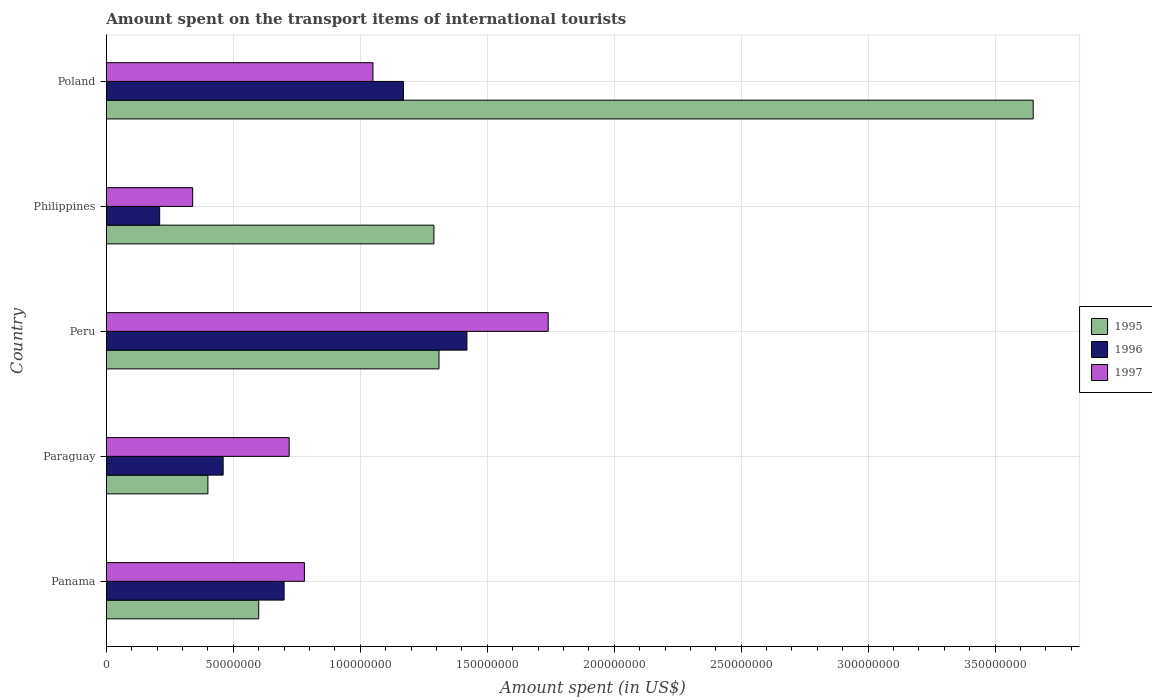Are the number of bars per tick equal to the number of legend labels?
Offer a terse response. Yes. Are the number of bars on each tick of the Y-axis equal?
Give a very brief answer. Yes. What is the label of the 4th group of bars from the top?
Your answer should be very brief. Paraguay. What is the amount spent on the transport items of international tourists in 1995 in Poland?
Offer a very short reply. 3.65e+08. Across all countries, what is the maximum amount spent on the transport items of international tourists in 1997?
Give a very brief answer. 1.74e+08. Across all countries, what is the minimum amount spent on the transport items of international tourists in 1997?
Your response must be concise. 3.40e+07. What is the total amount spent on the transport items of international tourists in 1995 in the graph?
Give a very brief answer. 7.25e+08. What is the difference between the amount spent on the transport items of international tourists in 1995 in Panama and that in Philippines?
Your answer should be very brief. -6.90e+07. What is the difference between the amount spent on the transport items of international tourists in 1996 in Peru and the amount spent on the transport items of international tourists in 1995 in Philippines?
Keep it short and to the point. 1.30e+07. What is the average amount spent on the transport items of international tourists in 1996 per country?
Offer a terse response. 7.92e+07. What is the difference between the amount spent on the transport items of international tourists in 1995 and amount spent on the transport items of international tourists in 1997 in Panama?
Provide a succinct answer. -1.80e+07. What is the ratio of the amount spent on the transport items of international tourists in 1996 in Peru to that in Poland?
Provide a short and direct response. 1.21. What is the difference between the highest and the second highest amount spent on the transport items of international tourists in 1996?
Your answer should be very brief. 2.50e+07. What is the difference between the highest and the lowest amount spent on the transport items of international tourists in 1996?
Provide a succinct answer. 1.21e+08. What does the 2nd bar from the top in Panama represents?
Your answer should be compact. 1996. What does the 1st bar from the bottom in Peru represents?
Keep it short and to the point. 1995. How many bars are there?
Provide a succinct answer. 15. Are all the bars in the graph horizontal?
Offer a terse response. Yes. What is the difference between two consecutive major ticks on the X-axis?
Provide a succinct answer. 5.00e+07. Does the graph contain any zero values?
Your answer should be compact. No. Where does the legend appear in the graph?
Offer a very short reply. Center right. How are the legend labels stacked?
Offer a very short reply. Vertical. What is the title of the graph?
Your answer should be very brief. Amount spent on the transport items of international tourists. What is the label or title of the X-axis?
Offer a terse response. Amount spent (in US$). What is the label or title of the Y-axis?
Make the answer very short. Country. What is the Amount spent (in US$) of 1995 in Panama?
Give a very brief answer. 6.00e+07. What is the Amount spent (in US$) in 1996 in Panama?
Your answer should be compact. 7.00e+07. What is the Amount spent (in US$) in 1997 in Panama?
Your answer should be very brief. 7.80e+07. What is the Amount spent (in US$) in 1995 in Paraguay?
Your answer should be compact. 4.00e+07. What is the Amount spent (in US$) in 1996 in Paraguay?
Ensure brevity in your answer.  4.60e+07. What is the Amount spent (in US$) of 1997 in Paraguay?
Your response must be concise. 7.20e+07. What is the Amount spent (in US$) of 1995 in Peru?
Your answer should be compact. 1.31e+08. What is the Amount spent (in US$) in 1996 in Peru?
Keep it short and to the point. 1.42e+08. What is the Amount spent (in US$) in 1997 in Peru?
Offer a terse response. 1.74e+08. What is the Amount spent (in US$) of 1995 in Philippines?
Your answer should be compact. 1.29e+08. What is the Amount spent (in US$) of 1996 in Philippines?
Your response must be concise. 2.10e+07. What is the Amount spent (in US$) of 1997 in Philippines?
Provide a short and direct response. 3.40e+07. What is the Amount spent (in US$) of 1995 in Poland?
Your answer should be very brief. 3.65e+08. What is the Amount spent (in US$) of 1996 in Poland?
Your answer should be compact. 1.17e+08. What is the Amount spent (in US$) in 1997 in Poland?
Make the answer very short. 1.05e+08. Across all countries, what is the maximum Amount spent (in US$) in 1995?
Your response must be concise. 3.65e+08. Across all countries, what is the maximum Amount spent (in US$) of 1996?
Provide a succinct answer. 1.42e+08. Across all countries, what is the maximum Amount spent (in US$) in 1997?
Your answer should be compact. 1.74e+08. Across all countries, what is the minimum Amount spent (in US$) of 1995?
Your answer should be very brief. 4.00e+07. Across all countries, what is the minimum Amount spent (in US$) of 1996?
Keep it short and to the point. 2.10e+07. Across all countries, what is the minimum Amount spent (in US$) in 1997?
Offer a very short reply. 3.40e+07. What is the total Amount spent (in US$) in 1995 in the graph?
Keep it short and to the point. 7.25e+08. What is the total Amount spent (in US$) of 1996 in the graph?
Keep it short and to the point. 3.96e+08. What is the total Amount spent (in US$) of 1997 in the graph?
Provide a short and direct response. 4.63e+08. What is the difference between the Amount spent (in US$) in 1996 in Panama and that in Paraguay?
Your answer should be very brief. 2.40e+07. What is the difference between the Amount spent (in US$) in 1995 in Panama and that in Peru?
Offer a terse response. -7.10e+07. What is the difference between the Amount spent (in US$) of 1996 in Panama and that in Peru?
Your answer should be very brief. -7.20e+07. What is the difference between the Amount spent (in US$) of 1997 in Panama and that in Peru?
Keep it short and to the point. -9.60e+07. What is the difference between the Amount spent (in US$) of 1995 in Panama and that in Philippines?
Offer a terse response. -6.90e+07. What is the difference between the Amount spent (in US$) of 1996 in Panama and that in Philippines?
Provide a short and direct response. 4.90e+07. What is the difference between the Amount spent (in US$) of 1997 in Panama and that in Philippines?
Provide a short and direct response. 4.40e+07. What is the difference between the Amount spent (in US$) in 1995 in Panama and that in Poland?
Your answer should be compact. -3.05e+08. What is the difference between the Amount spent (in US$) of 1996 in Panama and that in Poland?
Give a very brief answer. -4.70e+07. What is the difference between the Amount spent (in US$) of 1997 in Panama and that in Poland?
Offer a terse response. -2.70e+07. What is the difference between the Amount spent (in US$) of 1995 in Paraguay and that in Peru?
Keep it short and to the point. -9.10e+07. What is the difference between the Amount spent (in US$) in 1996 in Paraguay and that in Peru?
Make the answer very short. -9.60e+07. What is the difference between the Amount spent (in US$) in 1997 in Paraguay and that in Peru?
Offer a very short reply. -1.02e+08. What is the difference between the Amount spent (in US$) of 1995 in Paraguay and that in Philippines?
Give a very brief answer. -8.90e+07. What is the difference between the Amount spent (in US$) in 1996 in Paraguay and that in Philippines?
Give a very brief answer. 2.50e+07. What is the difference between the Amount spent (in US$) of 1997 in Paraguay and that in Philippines?
Offer a very short reply. 3.80e+07. What is the difference between the Amount spent (in US$) in 1995 in Paraguay and that in Poland?
Provide a short and direct response. -3.25e+08. What is the difference between the Amount spent (in US$) of 1996 in Paraguay and that in Poland?
Offer a terse response. -7.10e+07. What is the difference between the Amount spent (in US$) of 1997 in Paraguay and that in Poland?
Keep it short and to the point. -3.30e+07. What is the difference between the Amount spent (in US$) in 1996 in Peru and that in Philippines?
Ensure brevity in your answer.  1.21e+08. What is the difference between the Amount spent (in US$) of 1997 in Peru and that in Philippines?
Give a very brief answer. 1.40e+08. What is the difference between the Amount spent (in US$) of 1995 in Peru and that in Poland?
Ensure brevity in your answer.  -2.34e+08. What is the difference between the Amount spent (in US$) in 1996 in Peru and that in Poland?
Keep it short and to the point. 2.50e+07. What is the difference between the Amount spent (in US$) of 1997 in Peru and that in Poland?
Offer a very short reply. 6.90e+07. What is the difference between the Amount spent (in US$) of 1995 in Philippines and that in Poland?
Offer a very short reply. -2.36e+08. What is the difference between the Amount spent (in US$) in 1996 in Philippines and that in Poland?
Your response must be concise. -9.60e+07. What is the difference between the Amount spent (in US$) in 1997 in Philippines and that in Poland?
Ensure brevity in your answer.  -7.10e+07. What is the difference between the Amount spent (in US$) in 1995 in Panama and the Amount spent (in US$) in 1996 in Paraguay?
Make the answer very short. 1.40e+07. What is the difference between the Amount spent (in US$) of 1995 in Panama and the Amount spent (in US$) of 1997 in Paraguay?
Make the answer very short. -1.20e+07. What is the difference between the Amount spent (in US$) of 1995 in Panama and the Amount spent (in US$) of 1996 in Peru?
Your answer should be very brief. -8.20e+07. What is the difference between the Amount spent (in US$) of 1995 in Panama and the Amount spent (in US$) of 1997 in Peru?
Ensure brevity in your answer.  -1.14e+08. What is the difference between the Amount spent (in US$) in 1996 in Panama and the Amount spent (in US$) in 1997 in Peru?
Offer a very short reply. -1.04e+08. What is the difference between the Amount spent (in US$) in 1995 in Panama and the Amount spent (in US$) in 1996 in Philippines?
Ensure brevity in your answer.  3.90e+07. What is the difference between the Amount spent (in US$) of 1995 in Panama and the Amount spent (in US$) of 1997 in Philippines?
Ensure brevity in your answer.  2.60e+07. What is the difference between the Amount spent (in US$) of 1996 in Panama and the Amount spent (in US$) of 1997 in Philippines?
Ensure brevity in your answer.  3.60e+07. What is the difference between the Amount spent (in US$) in 1995 in Panama and the Amount spent (in US$) in 1996 in Poland?
Make the answer very short. -5.70e+07. What is the difference between the Amount spent (in US$) of 1995 in Panama and the Amount spent (in US$) of 1997 in Poland?
Provide a succinct answer. -4.50e+07. What is the difference between the Amount spent (in US$) in 1996 in Panama and the Amount spent (in US$) in 1997 in Poland?
Provide a succinct answer. -3.50e+07. What is the difference between the Amount spent (in US$) in 1995 in Paraguay and the Amount spent (in US$) in 1996 in Peru?
Your answer should be compact. -1.02e+08. What is the difference between the Amount spent (in US$) in 1995 in Paraguay and the Amount spent (in US$) in 1997 in Peru?
Offer a very short reply. -1.34e+08. What is the difference between the Amount spent (in US$) in 1996 in Paraguay and the Amount spent (in US$) in 1997 in Peru?
Provide a succinct answer. -1.28e+08. What is the difference between the Amount spent (in US$) in 1995 in Paraguay and the Amount spent (in US$) in 1996 in Philippines?
Your answer should be compact. 1.90e+07. What is the difference between the Amount spent (in US$) of 1995 in Paraguay and the Amount spent (in US$) of 1996 in Poland?
Ensure brevity in your answer.  -7.70e+07. What is the difference between the Amount spent (in US$) of 1995 in Paraguay and the Amount spent (in US$) of 1997 in Poland?
Keep it short and to the point. -6.50e+07. What is the difference between the Amount spent (in US$) in 1996 in Paraguay and the Amount spent (in US$) in 1997 in Poland?
Keep it short and to the point. -5.90e+07. What is the difference between the Amount spent (in US$) in 1995 in Peru and the Amount spent (in US$) in 1996 in Philippines?
Offer a terse response. 1.10e+08. What is the difference between the Amount spent (in US$) of 1995 in Peru and the Amount spent (in US$) of 1997 in Philippines?
Give a very brief answer. 9.70e+07. What is the difference between the Amount spent (in US$) in 1996 in Peru and the Amount spent (in US$) in 1997 in Philippines?
Your response must be concise. 1.08e+08. What is the difference between the Amount spent (in US$) of 1995 in Peru and the Amount spent (in US$) of 1996 in Poland?
Offer a terse response. 1.40e+07. What is the difference between the Amount spent (in US$) in 1995 in Peru and the Amount spent (in US$) in 1997 in Poland?
Make the answer very short. 2.60e+07. What is the difference between the Amount spent (in US$) of 1996 in Peru and the Amount spent (in US$) of 1997 in Poland?
Your answer should be compact. 3.70e+07. What is the difference between the Amount spent (in US$) of 1995 in Philippines and the Amount spent (in US$) of 1996 in Poland?
Your answer should be compact. 1.20e+07. What is the difference between the Amount spent (in US$) in 1995 in Philippines and the Amount spent (in US$) in 1997 in Poland?
Make the answer very short. 2.40e+07. What is the difference between the Amount spent (in US$) in 1996 in Philippines and the Amount spent (in US$) in 1997 in Poland?
Your response must be concise. -8.40e+07. What is the average Amount spent (in US$) in 1995 per country?
Provide a short and direct response. 1.45e+08. What is the average Amount spent (in US$) in 1996 per country?
Your answer should be very brief. 7.92e+07. What is the average Amount spent (in US$) of 1997 per country?
Provide a succinct answer. 9.26e+07. What is the difference between the Amount spent (in US$) of 1995 and Amount spent (in US$) of 1996 in Panama?
Offer a very short reply. -1.00e+07. What is the difference between the Amount spent (in US$) of 1995 and Amount spent (in US$) of 1997 in Panama?
Provide a short and direct response. -1.80e+07. What is the difference between the Amount spent (in US$) in 1996 and Amount spent (in US$) in 1997 in Panama?
Provide a short and direct response. -8.00e+06. What is the difference between the Amount spent (in US$) in 1995 and Amount spent (in US$) in 1996 in Paraguay?
Keep it short and to the point. -6.00e+06. What is the difference between the Amount spent (in US$) in 1995 and Amount spent (in US$) in 1997 in Paraguay?
Ensure brevity in your answer.  -3.20e+07. What is the difference between the Amount spent (in US$) of 1996 and Amount spent (in US$) of 1997 in Paraguay?
Keep it short and to the point. -2.60e+07. What is the difference between the Amount spent (in US$) of 1995 and Amount spent (in US$) of 1996 in Peru?
Provide a succinct answer. -1.10e+07. What is the difference between the Amount spent (in US$) in 1995 and Amount spent (in US$) in 1997 in Peru?
Ensure brevity in your answer.  -4.30e+07. What is the difference between the Amount spent (in US$) in 1996 and Amount spent (in US$) in 1997 in Peru?
Keep it short and to the point. -3.20e+07. What is the difference between the Amount spent (in US$) in 1995 and Amount spent (in US$) in 1996 in Philippines?
Keep it short and to the point. 1.08e+08. What is the difference between the Amount spent (in US$) in 1995 and Amount spent (in US$) in 1997 in Philippines?
Your answer should be very brief. 9.50e+07. What is the difference between the Amount spent (in US$) in 1996 and Amount spent (in US$) in 1997 in Philippines?
Make the answer very short. -1.30e+07. What is the difference between the Amount spent (in US$) in 1995 and Amount spent (in US$) in 1996 in Poland?
Your response must be concise. 2.48e+08. What is the difference between the Amount spent (in US$) of 1995 and Amount spent (in US$) of 1997 in Poland?
Provide a short and direct response. 2.60e+08. What is the ratio of the Amount spent (in US$) of 1996 in Panama to that in Paraguay?
Your response must be concise. 1.52. What is the ratio of the Amount spent (in US$) in 1997 in Panama to that in Paraguay?
Your response must be concise. 1.08. What is the ratio of the Amount spent (in US$) in 1995 in Panama to that in Peru?
Your response must be concise. 0.46. What is the ratio of the Amount spent (in US$) in 1996 in Panama to that in Peru?
Keep it short and to the point. 0.49. What is the ratio of the Amount spent (in US$) in 1997 in Panama to that in Peru?
Your answer should be very brief. 0.45. What is the ratio of the Amount spent (in US$) of 1995 in Panama to that in Philippines?
Your answer should be very brief. 0.47. What is the ratio of the Amount spent (in US$) of 1996 in Panama to that in Philippines?
Keep it short and to the point. 3.33. What is the ratio of the Amount spent (in US$) of 1997 in Panama to that in Philippines?
Your response must be concise. 2.29. What is the ratio of the Amount spent (in US$) of 1995 in Panama to that in Poland?
Provide a short and direct response. 0.16. What is the ratio of the Amount spent (in US$) in 1996 in Panama to that in Poland?
Your answer should be very brief. 0.6. What is the ratio of the Amount spent (in US$) in 1997 in Panama to that in Poland?
Keep it short and to the point. 0.74. What is the ratio of the Amount spent (in US$) of 1995 in Paraguay to that in Peru?
Offer a terse response. 0.31. What is the ratio of the Amount spent (in US$) in 1996 in Paraguay to that in Peru?
Ensure brevity in your answer.  0.32. What is the ratio of the Amount spent (in US$) of 1997 in Paraguay to that in Peru?
Ensure brevity in your answer.  0.41. What is the ratio of the Amount spent (in US$) in 1995 in Paraguay to that in Philippines?
Ensure brevity in your answer.  0.31. What is the ratio of the Amount spent (in US$) in 1996 in Paraguay to that in Philippines?
Your answer should be very brief. 2.19. What is the ratio of the Amount spent (in US$) in 1997 in Paraguay to that in Philippines?
Provide a succinct answer. 2.12. What is the ratio of the Amount spent (in US$) in 1995 in Paraguay to that in Poland?
Your answer should be compact. 0.11. What is the ratio of the Amount spent (in US$) in 1996 in Paraguay to that in Poland?
Provide a succinct answer. 0.39. What is the ratio of the Amount spent (in US$) in 1997 in Paraguay to that in Poland?
Give a very brief answer. 0.69. What is the ratio of the Amount spent (in US$) in 1995 in Peru to that in Philippines?
Keep it short and to the point. 1.02. What is the ratio of the Amount spent (in US$) in 1996 in Peru to that in Philippines?
Provide a short and direct response. 6.76. What is the ratio of the Amount spent (in US$) in 1997 in Peru to that in Philippines?
Provide a succinct answer. 5.12. What is the ratio of the Amount spent (in US$) of 1995 in Peru to that in Poland?
Your response must be concise. 0.36. What is the ratio of the Amount spent (in US$) of 1996 in Peru to that in Poland?
Your answer should be very brief. 1.21. What is the ratio of the Amount spent (in US$) in 1997 in Peru to that in Poland?
Ensure brevity in your answer.  1.66. What is the ratio of the Amount spent (in US$) in 1995 in Philippines to that in Poland?
Offer a terse response. 0.35. What is the ratio of the Amount spent (in US$) in 1996 in Philippines to that in Poland?
Your answer should be very brief. 0.18. What is the ratio of the Amount spent (in US$) in 1997 in Philippines to that in Poland?
Provide a short and direct response. 0.32. What is the difference between the highest and the second highest Amount spent (in US$) of 1995?
Your response must be concise. 2.34e+08. What is the difference between the highest and the second highest Amount spent (in US$) of 1996?
Your answer should be compact. 2.50e+07. What is the difference between the highest and the second highest Amount spent (in US$) in 1997?
Offer a very short reply. 6.90e+07. What is the difference between the highest and the lowest Amount spent (in US$) of 1995?
Offer a terse response. 3.25e+08. What is the difference between the highest and the lowest Amount spent (in US$) of 1996?
Make the answer very short. 1.21e+08. What is the difference between the highest and the lowest Amount spent (in US$) of 1997?
Provide a succinct answer. 1.40e+08. 